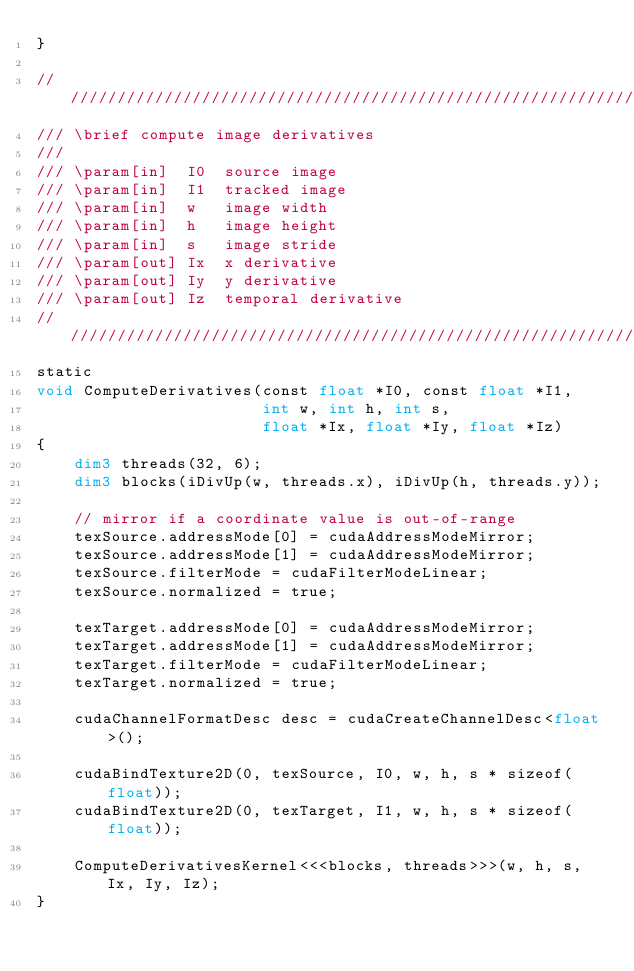<code> <loc_0><loc_0><loc_500><loc_500><_Cuda_>}

///////////////////////////////////////////////////////////////////////////////
/// \brief compute image derivatives
///
/// \param[in]  I0  source image
/// \param[in]  I1  tracked image
/// \param[in]  w   image width
/// \param[in]  h   image height
/// \param[in]  s   image stride
/// \param[out] Ix  x derivative
/// \param[out] Iy  y derivative
/// \param[out] Iz  temporal derivative
///////////////////////////////////////////////////////////////////////////////
static
void ComputeDerivatives(const float *I0, const float *I1,
                        int w, int h, int s,
                        float *Ix, float *Iy, float *Iz)
{
    dim3 threads(32, 6);
    dim3 blocks(iDivUp(w, threads.x), iDivUp(h, threads.y));

    // mirror if a coordinate value is out-of-range
    texSource.addressMode[0] = cudaAddressModeMirror;
    texSource.addressMode[1] = cudaAddressModeMirror;
    texSource.filterMode = cudaFilterModeLinear;
    texSource.normalized = true;

    texTarget.addressMode[0] = cudaAddressModeMirror;
    texTarget.addressMode[1] = cudaAddressModeMirror;
    texTarget.filterMode = cudaFilterModeLinear;
    texTarget.normalized = true;

    cudaChannelFormatDesc desc = cudaCreateChannelDesc<float>();

    cudaBindTexture2D(0, texSource, I0, w, h, s * sizeof(float));
    cudaBindTexture2D(0, texTarget, I1, w, h, s * sizeof(float));

    ComputeDerivativesKernel<<<blocks, threads>>>(w, h, s, Ix, Iy, Iz);
}
</code> 